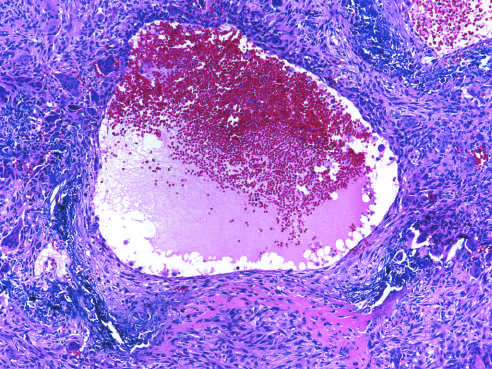s flow cytometry surrounded by a fibrous wall containing proliferating fibroblasts, reactive woven bone, and osteoclast-type giant cells?
Answer the question using a single word or phrase. No 